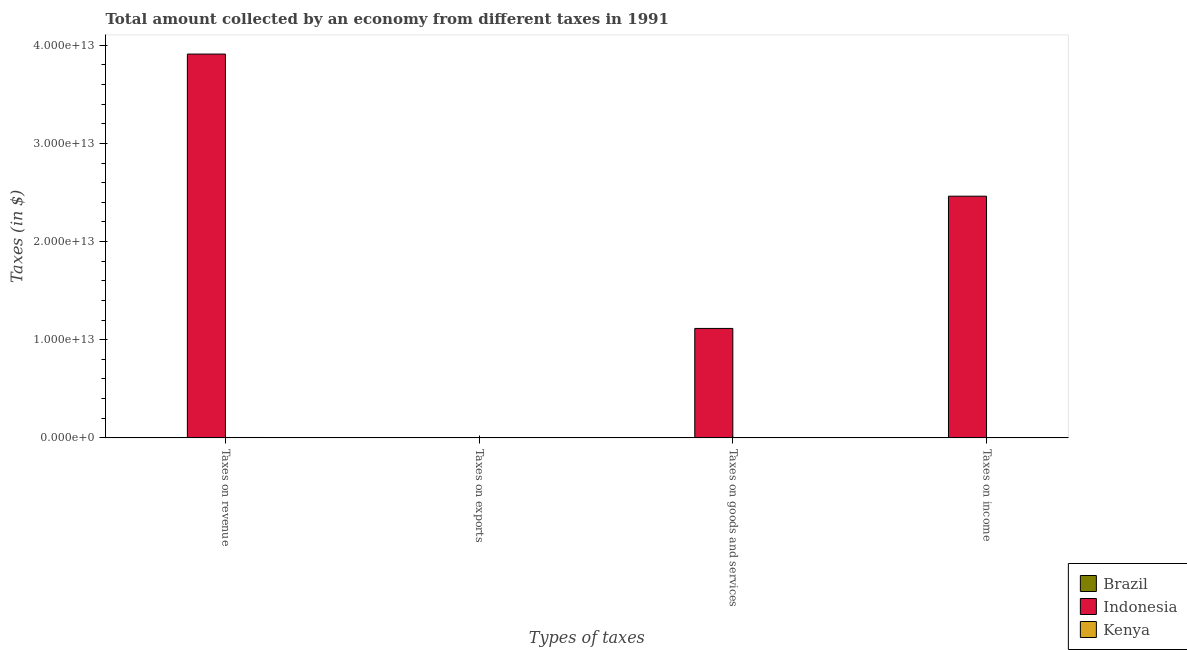How many different coloured bars are there?
Give a very brief answer. 3. How many bars are there on the 2nd tick from the left?
Keep it short and to the point. 3. How many bars are there on the 3rd tick from the right?
Your response must be concise. 3. What is the label of the 2nd group of bars from the left?
Keep it short and to the point. Taxes on exports. What is the amount collected as tax on goods in Indonesia?
Your answer should be compact. 1.11e+13. Across all countries, what is the maximum amount collected as tax on income?
Ensure brevity in your answer.  2.46e+13. Across all countries, what is the minimum amount collected as tax on revenue?
Provide a short and direct response. 5.75e+06. In which country was the amount collected as tax on goods minimum?
Your answer should be compact. Brazil. What is the total amount collected as tax on goods in the graph?
Provide a succinct answer. 1.12e+13. What is the difference between the amount collected as tax on goods in Kenya and that in Indonesia?
Provide a short and direct response. -1.11e+13. What is the difference between the amount collected as tax on income in Kenya and the amount collected as tax on exports in Brazil?
Your answer should be very brief. 1.30e+1. What is the average amount collected as tax on exports per country?
Your answer should be compact. 6.34e+09. What is the difference between the amount collected as tax on income and amount collected as tax on exports in Indonesia?
Keep it short and to the point. 2.46e+13. What is the ratio of the amount collected as tax on income in Kenya to that in Brazil?
Ensure brevity in your answer.  6038.81. Is the amount collected as tax on exports in Indonesia less than that in Kenya?
Your response must be concise. No. What is the difference between the highest and the second highest amount collected as tax on income?
Make the answer very short. 2.46e+13. What is the difference between the highest and the lowest amount collected as tax on exports?
Keep it short and to the point. 1.90e+1. Is the sum of the amount collected as tax on revenue in Kenya and Indonesia greater than the maximum amount collected as tax on income across all countries?
Make the answer very short. Yes. What does the 3rd bar from the left in Taxes on income represents?
Make the answer very short. Kenya. What does the 3rd bar from the right in Taxes on revenue represents?
Offer a terse response. Brazil. Is it the case that in every country, the sum of the amount collected as tax on revenue and amount collected as tax on exports is greater than the amount collected as tax on goods?
Make the answer very short. Yes. How many bars are there?
Your answer should be compact. 12. What is the difference between two consecutive major ticks on the Y-axis?
Offer a very short reply. 1.00e+13. Are the values on the major ticks of Y-axis written in scientific E-notation?
Your response must be concise. Yes. Does the graph contain any zero values?
Offer a very short reply. No. Does the graph contain grids?
Offer a terse response. No. Where does the legend appear in the graph?
Provide a short and direct response. Bottom right. What is the title of the graph?
Offer a terse response. Total amount collected by an economy from different taxes in 1991. What is the label or title of the X-axis?
Your answer should be very brief. Types of taxes. What is the label or title of the Y-axis?
Your answer should be very brief. Taxes (in $). What is the Taxes (in $) in Brazil in Taxes on revenue?
Provide a short and direct response. 5.75e+06. What is the Taxes (in $) in Indonesia in Taxes on revenue?
Your response must be concise. 3.91e+13. What is the Taxes (in $) in Kenya in Taxes on revenue?
Give a very brief answer. 3.95e+1. What is the Taxes (in $) of Brazil in Taxes on exports?
Provide a short and direct response. 1527.27. What is the Taxes (in $) of Indonesia in Taxes on exports?
Your answer should be very brief. 1.90e+1. What is the Taxes (in $) in Kenya in Taxes on exports?
Give a very brief answer. 1.50e+07. What is the Taxes (in $) in Brazil in Taxes on goods and services?
Your answer should be very brief. 2.67e+06. What is the Taxes (in $) in Indonesia in Taxes on goods and services?
Offer a terse response. 1.11e+13. What is the Taxes (in $) in Kenya in Taxes on goods and services?
Your response must be concise. 1.89e+1. What is the Taxes (in $) in Brazil in Taxes on income?
Give a very brief answer. 2.15e+06. What is the Taxes (in $) in Indonesia in Taxes on income?
Make the answer very short. 2.46e+13. What is the Taxes (in $) in Kenya in Taxes on income?
Ensure brevity in your answer.  1.30e+1. Across all Types of taxes, what is the maximum Taxes (in $) in Brazil?
Your answer should be very brief. 5.75e+06. Across all Types of taxes, what is the maximum Taxes (in $) in Indonesia?
Give a very brief answer. 3.91e+13. Across all Types of taxes, what is the maximum Taxes (in $) in Kenya?
Your response must be concise. 3.95e+1. Across all Types of taxes, what is the minimum Taxes (in $) in Brazil?
Provide a short and direct response. 1527.27. Across all Types of taxes, what is the minimum Taxes (in $) in Indonesia?
Provide a short and direct response. 1.90e+1. Across all Types of taxes, what is the minimum Taxes (in $) of Kenya?
Offer a very short reply. 1.50e+07. What is the total Taxes (in $) of Brazil in the graph?
Your response must be concise. 1.06e+07. What is the total Taxes (in $) of Indonesia in the graph?
Make the answer very short. 7.49e+13. What is the total Taxes (in $) in Kenya in the graph?
Make the answer very short. 7.14e+1. What is the difference between the Taxes (in $) of Brazil in Taxes on revenue and that in Taxes on exports?
Keep it short and to the point. 5.74e+06. What is the difference between the Taxes (in $) of Indonesia in Taxes on revenue and that in Taxes on exports?
Give a very brief answer. 3.91e+13. What is the difference between the Taxes (in $) in Kenya in Taxes on revenue and that in Taxes on exports?
Make the answer very short. 3.95e+1. What is the difference between the Taxes (in $) in Brazil in Taxes on revenue and that in Taxes on goods and services?
Provide a short and direct response. 3.07e+06. What is the difference between the Taxes (in $) of Indonesia in Taxes on revenue and that in Taxes on goods and services?
Provide a succinct answer. 2.79e+13. What is the difference between the Taxes (in $) in Kenya in Taxes on revenue and that in Taxes on goods and services?
Provide a succinct answer. 2.06e+1. What is the difference between the Taxes (in $) of Brazil in Taxes on revenue and that in Taxes on income?
Your answer should be very brief. 3.60e+06. What is the difference between the Taxes (in $) of Indonesia in Taxes on revenue and that in Taxes on income?
Make the answer very short. 1.45e+13. What is the difference between the Taxes (in $) in Kenya in Taxes on revenue and that in Taxes on income?
Offer a terse response. 2.65e+1. What is the difference between the Taxes (in $) of Brazil in Taxes on exports and that in Taxes on goods and services?
Make the answer very short. -2.67e+06. What is the difference between the Taxes (in $) of Indonesia in Taxes on exports and that in Taxes on goods and services?
Your answer should be very brief. -1.11e+13. What is the difference between the Taxes (in $) in Kenya in Taxes on exports and that in Taxes on goods and services?
Ensure brevity in your answer.  -1.89e+1. What is the difference between the Taxes (in $) of Brazil in Taxes on exports and that in Taxes on income?
Ensure brevity in your answer.  -2.15e+06. What is the difference between the Taxes (in $) in Indonesia in Taxes on exports and that in Taxes on income?
Offer a terse response. -2.46e+13. What is the difference between the Taxes (in $) of Kenya in Taxes on exports and that in Taxes on income?
Your answer should be compact. -1.30e+1. What is the difference between the Taxes (in $) of Brazil in Taxes on goods and services and that in Taxes on income?
Make the answer very short. 5.20e+05. What is the difference between the Taxes (in $) in Indonesia in Taxes on goods and services and that in Taxes on income?
Provide a succinct answer. -1.35e+13. What is the difference between the Taxes (in $) of Kenya in Taxes on goods and services and that in Taxes on income?
Offer a very short reply. 5.91e+09. What is the difference between the Taxes (in $) of Brazil in Taxes on revenue and the Taxes (in $) of Indonesia in Taxes on exports?
Provide a succinct answer. -1.90e+1. What is the difference between the Taxes (in $) in Brazil in Taxes on revenue and the Taxes (in $) in Kenya in Taxes on exports?
Your response must be concise. -9.25e+06. What is the difference between the Taxes (in $) in Indonesia in Taxes on revenue and the Taxes (in $) in Kenya in Taxes on exports?
Your answer should be very brief. 3.91e+13. What is the difference between the Taxes (in $) in Brazil in Taxes on revenue and the Taxes (in $) in Indonesia in Taxes on goods and services?
Your answer should be compact. -1.11e+13. What is the difference between the Taxes (in $) in Brazil in Taxes on revenue and the Taxes (in $) in Kenya in Taxes on goods and services?
Offer a very short reply. -1.89e+1. What is the difference between the Taxes (in $) of Indonesia in Taxes on revenue and the Taxes (in $) of Kenya in Taxes on goods and services?
Provide a succinct answer. 3.91e+13. What is the difference between the Taxes (in $) in Brazil in Taxes on revenue and the Taxes (in $) in Indonesia in Taxes on income?
Your answer should be very brief. -2.46e+13. What is the difference between the Taxes (in $) of Brazil in Taxes on revenue and the Taxes (in $) of Kenya in Taxes on income?
Provide a short and direct response. -1.30e+1. What is the difference between the Taxes (in $) in Indonesia in Taxes on revenue and the Taxes (in $) in Kenya in Taxes on income?
Your answer should be very brief. 3.91e+13. What is the difference between the Taxes (in $) of Brazil in Taxes on exports and the Taxes (in $) of Indonesia in Taxes on goods and services?
Give a very brief answer. -1.11e+13. What is the difference between the Taxes (in $) of Brazil in Taxes on exports and the Taxes (in $) of Kenya in Taxes on goods and services?
Provide a short and direct response. -1.89e+1. What is the difference between the Taxes (in $) of Indonesia in Taxes on exports and the Taxes (in $) of Kenya in Taxes on goods and services?
Provide a succinct answer. 1.04e+08. What is the difference between the Taxes (in $) of Brazil in Taxes on exports and the Taxes (in $) of Indonesia in Taxes on income?
Your answer should be compact. -2.46e+13. What is the difference between the Taxes (in $) in Brazil in Taxes on exports and the Taxes (in $) in Kenya in Taxes on income?
Offer a very short reply. -1.30e+1. What is the difference between the Taxes (in $) in Indonesia in Taxes on exports and the Taxes (in $) in Kenya in Taxes on income?
Provide a succinct answer. 6.02e+09. What is the difference between the Taxes (in $) in Brazil in Taxes on goods and services and the Taxes (in $) in Indonesia in Taxes on income?
Your response must be concise. -2.46e+13. What is the difference between the Taxes (in $) in Brazil in Taxes on goods and services and the Taxes (in $) in Kenya in Taxes on income?
Your answer should be compact. -1.30e+1. What is the difference between the Taxes (in $) of Indonesia in Taxes on goods and services and the Taxes (in $) of Kenya in Taxes on income?
Give a very brief answer. 1.11e+13. What is the average Taxes (in $) of Brazil per Types of taxes?
Keep it short and to the point. 2.64e+06. What is the average Taxes (in $) of Indonesia per Types of taxes?
Provide a short and direct response. 1.87e+13. What is the average Taxes (in $) of Kenya per Types of taxes?
Give a very brief answer. 1.79e+1. What is the difference between the Taxes (in $) of Brazil and Taxes (in $) of Indonesia in Taxes on revenue?
Your answer should be compact. -3.91e+13. What is the difference between the Taxes (in $) in Brazil and Taxes (in $) in Kenya in Taxes on revenue?
Give a very brief answer. -3.95e+1. What is the difference between the Taxes (in $) in Indonesia and Taxes (in $) in Kenya in Taxes on revenue?
Your response must be concise. 3.91e+13. What is the difference between the Taxes (in $) in Brazil and Taxes (in $) in Indonesia in Taxes on exports?
Provide a short and direct response. -1.90e+1. What is the difference between the Taxes (in $) in Brazil and Taxes (in $) in Kenya in Taxes on exports?
Your answer should be very brief. -1.50e+07. What is the difference between the Taxes (in $) in Indonesia and Taxes (in $) in Kenya in Taxes on exports?
Ensure brevity in your answer.  1.90e+1. What is the difference between the Taxes (in $) of Brazil and Taxes (in $) of Indonesia in Taxes on goods and services?
Ensure brevity in your answer.  -1.11e+13. What is the difference between the Taxes (in $) in Brazil and Taxes (in $) in Kenya in Taxes on goods and services?
Provide a succinct answer. -1.89e+1. What is the difference between the Taxes (in $) in Indonesia and Taxes (in $) in Kenya in Taxes on goods and services?
Offer a very short reply. 1.11e+13. What is the difference between the Taxes (in $) of Brazil and Taxes (in $) of Indonesia in Taxes on income?
Your answer should be very brief. -2.46e+13. What is the difference between the Taxes (in $) in Brazil and Taxes (in $) in Kenya in Taxes on income?
Offer a terse response. -1.30e+1. What is the difference between the Taxes (in $) of Indonesia and Taxes (in $) of Kenya in Taxes on income?
Your answer should be very brief. 2.46e+13. What is the ratio of the Taxes (in $) in Brazil in Taxes on revenue to that in Taxes on exports?
Provide a succinct answer. 3761.67. What is the ratio of the Taxes (in $) in Indonesia in Taxes on revenue to that in Taxes on exports?
Make the answer very short. 2057.79. What is the ratio of the Taxes (in $) in Kenya in Taxes on revenue to that in Taxes on exports?
Your answer should be compact. 2634.53. What is the ratio of the Taxes (in $) of Brazil in Taxes on revenue to that in Taxes on goods and services?
Make the answer very short. 2.15. What is the ratio of the Taxes (in $) in Indonesia in Taxes on revenue to that in Taxes on goods and services?
Your answer should be compact. 3.51. What is the ratio of the Taxes (in $) in Kenya in Taxes on revenue to that in Taxes on goods and services?
Provide a succinct answer. 2.09. What is the ratio of the Taxes (in $) of Brazil in Taxes on revenue to that in Taxes on income?
Your answer should be very brief. 2.67. What is the ratio of the Taxes (in $) in Indonesia in Taxes on revenue to that in Taxes on income?
Provide a succinct answer. 1.59. What is the ratio of the Taxes (in $) in Kenya in Taxes on revenue to that in Taxes on income?
Give a very brief answer. 3.04. What is the ratio of the Taxes (in $) of Brazil in Taxes on exports to that in Taxes on goods and services?
Provide a short and direct response. 0. What is the ratio of the Taxes (in $) of Indonesia in Taxes on exports to that in Taxes on goods and services?
Your response must be concise. 0. What is the ratio of the Taxes (in $) of Kenya in Taxes on exports to that in Taxes on goods and services?
Ensure brevity in your answer.  0. What is the ratio of the Taxes (in $) of Brazil in Taxes on exports to that in Taxes on income?
Offer a very short reply. 0. What is the ratio of the Taxes (in $) of Indonesia in Taxes on exports to that in Taxes on income?
Offer a terse response. 0. What is the ratio of the Taxes (in $) in Kenya in Taxes on exports to that in Taxes on income?
Provide a succinct answer. 0. What is the ratio of the Taxes (in $) of Brazil in Taxes on goods and services to that in Taxes on income?
Provide a short and direct response. 1.24. What is the ratio of the Taxes (in $) of Indonesia in Taxes on goods and services to that in Taxes on income?
Make the answer very short. 0.45. What is the ratio of the Taxes (in $) of Kenya in Taxes on goods and services to that in Taxes on income?
Ensure brevity in your answer.  1.46. What is the difference between the highest and the second highest Taxes (in $) in Brazil?
Your answer should be compact. 3.07e+06. What is the difference between the highest and the second highest Taxes (in $) in Indonesia?
Your answer should be compact. 1.45e+13. What is the difference between the highest and the second highest Taxes (in $) in Kenya?
Give a very brief answer. 2.06e+1. What is the difference between the highest and the lowest Taxes (in $) of Brazil?
Make the answer very short. 5.74e+06. What is the difference between the highest and the lowest Taxes (in $) in Indonesia?
Make the answer very short. 3.91e+13. What is the difference between the highest and the lowest Taxes (in $) in Kenya?
Provide a short and direct response. 3.95e+1. 